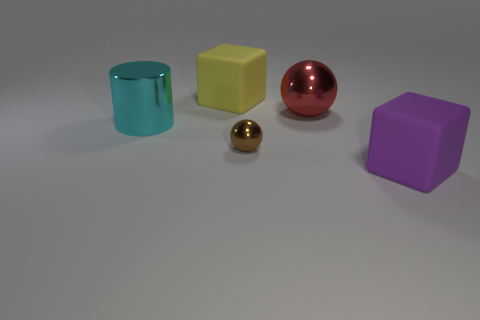Are there any other things that are the same size as the brown shiny object?
Ensure brevity in your answer.  No. There is a metal thing behind the large cyan shiny object; does it have the same shape as the large purple thing?
Provide a succinct answer. No. There is a large metal thing in front of the red metallic object on the right side of the large cyan metal thing on the left side of the small brown ball; what is its shape?
Your response must be concise. Cylinder. How big is the cyan cylinder?
Provide a short and direct response. Large. The object that is made of the same material as the big yellow cube is what color?
Give a very brief answer. Purple. How many big cylinders have the same material as the red sphere?
Make the answer very short. 1. There is a cylinder; is it the same color as the large matte block that is behind the purple block?
Your answer should be very brief. No. The matte thing behind the big matte block that is in front of the tiny brown thing is what color?
Your response must be concise. Yellow. What color is the metal sphere that is the same size as the cyan metal cylinder?
Ensure brevity in your answer.  Red. Are there any tiny metallic objects of the same shape as the yellow matte object?
Offer a very short reply. No. 